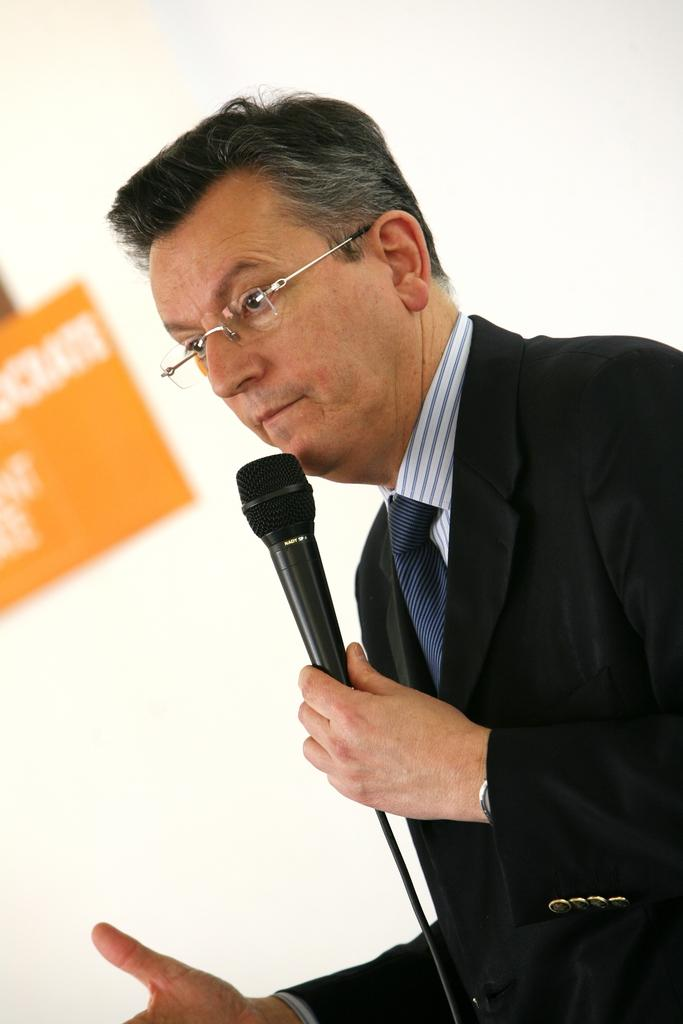Who is present in the image? There is a man in the image. What is the man holding in the image? The man is holding a microphone. What is the man wearing in the image? The man is wearing a black suit. What can be seen in the background of the image? There are hoardings visible in the background of the image. How does the man react to the earthquake in the image? There is no earthquake present in the image, so the man's reaction cannot be determined. 